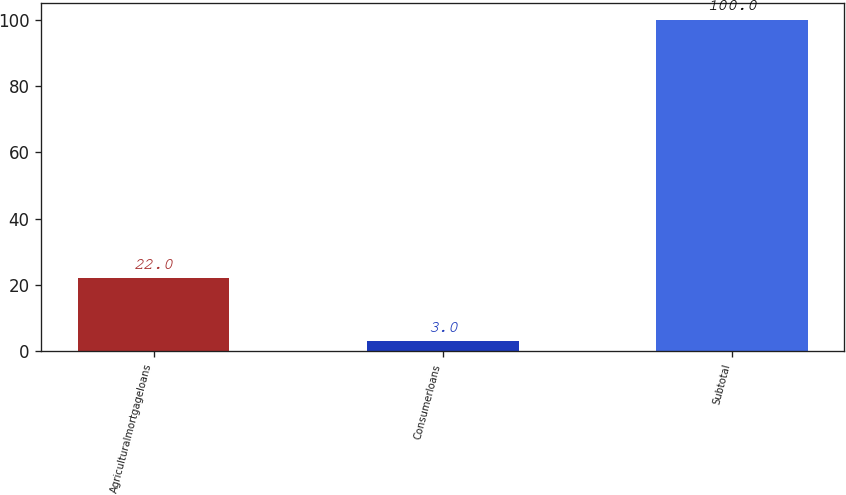<chart> <loc_0><loc_0><loc_500><loc_500><bar_chart><fcel>Agriculturalmortgageloans<fcel>Consumerloans<fcel>Subtotal<nl><fcel>22<fcel>3<fcel>100<nl></chart> 